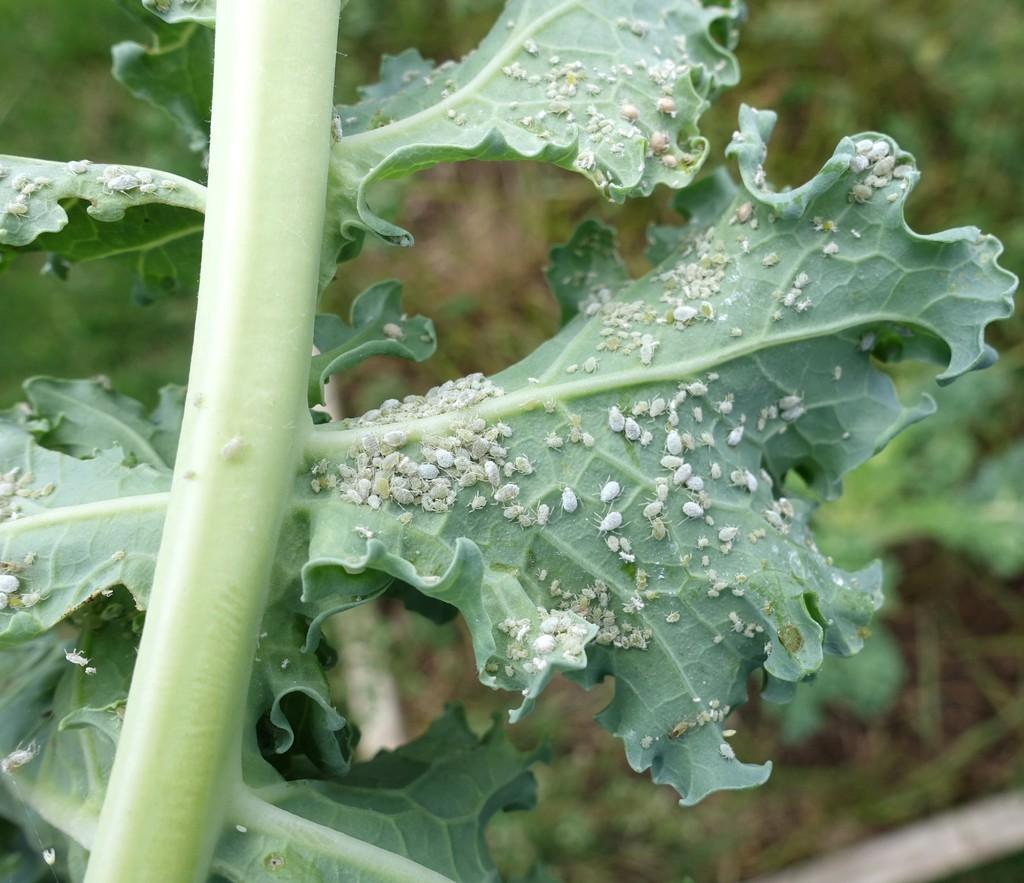What type of living organisms can be seen in the image? Plants can be seen in the image. What is the color of the plants in the image? The plants are green in color. What type of pest can be seen on the plants in the image? There is no pest visible on the plants in the image. What type of collar is being worn by the plants in the image? Plants do not wear collars, so this question is not applicable to the image. 